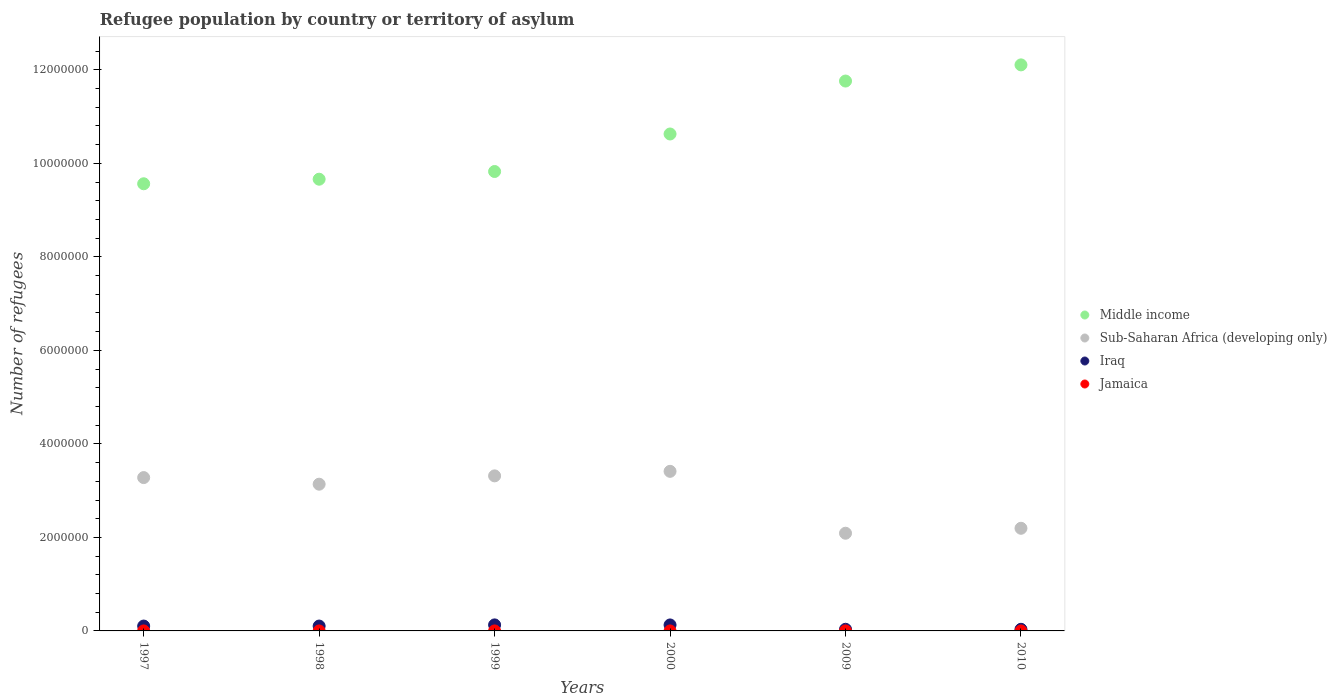How many different coloured dotlines are there?
Offer a very short reply. 4. Across all years, what is the maximum number of refugees in Middle income?
Keep it short and to the point. 1.21e+07. Across all years, what is the minimum number of refugees in Iraq?
Offer a terse response. 3.47e+04. In which year was the number of refugees in Iraq maximum?
Your answer should be compact. 1999. In which year was the number of refugees in Iraq minimum?
Your response must be concise. 2010. What is the total number of refugees in Sub-Saharan Africa (developing only) in the graph?
Ensure brevity in your answer.  1.74e+07. What is the difference between the number of refugees in Sub-Saharan Africa (developing only) in 1998 and that in 2010?
Your response must be concise. 9.43e+05. What is the difference between the number of refugees in Sub-Saharan Africa (developing only) in 1997 and the number of refugees in Jamaica in 2009?
Your response must be concise. 3.28e+06. What is the average number of refugees in Middle income per year?
Your answer should be very brief. 1.06e+07. In the year 2009, what is the difference between the number of refugees in Middle income and number of refugees in Jamaica?
Make the answer very short. 1.18e+07. What is the ratio of the number of refugees in Iraq in 2000 to that in 2009?
Give a very brief answer. 3.63. Is the number of refugees in Sub-Saharan Africa (developing only) in 1997 less than that in 2009?
Keep it short and to the point. No. Is the difference between the number of refugees in Middle income in 2009 and 2010 greater than the difference between the number of refugees in Jamaica in 2009 and 2010?
Provide a succinct answer. No. What is the difference between the highest and the second highest number of refugees in Iraq?
Give a very brief answer. 1126. What is the difference between the highest and the lowest number of refugees in Jamaica?
Provide a short and direct response. 17. In how many years, is the number of refugees in Sub-Saharan Africa (developing only) greater than the average number of refugees in Sub-Saharan Africa (developing only) taken over all years?
Your answer should be compact. 4. Is it the case that in every year, the sum of the number of refugees in Middle income and number of refugees in Iraq  is greater than the sum of number of refugees in Sub-Saharan Africa (developing only) and number of refugees in Jamaica?
Ensure brevity in your answer.  Yes. Does the number of refugees in Jamaica monotonically increase over the years?
Keep it short and to the point. No. Is the number of refugees in Iraq strictly less than the number of refugees in Jamaica over the years?
Keep it short and to the point. No. How many dotlines are there?
Provide a succinct answer. 4. How many years are there in the graph?
Provide a short and direct response. 6. What is the difference between two consecutive major ticks on the Y-axis?
Ensure brevity in your answer.  2.00e+06. Does the graph contain any zero values?
Provide a short and direct response. No. Does the graph contain grids?
Offer a terse response. No. How many legend labels are there?
Provide a succinct answer. 4. What is the title of the graph?
Your response must be concise. Refugee population by country or territory of asylum. Does "Gabon" appear as one of the legend labels in the graph?
Make the answer very short. No. What is the label or title of the X-axis?
Give a very brief answer. Years. What is the label or title of the Y-axis?
Provide a short and direct response. Number of refugees. What is the Number of refugees of Middle income in 1997?
Your response must be concise. 9.56e+06. What is the Number of refugees of Sub-Saharan Africa (developing only) in 1997?
Give a very brief answer. 3.28e+06. What is the Number of refugees in Iraq in 1997?
Your response must be concise. 1.04e+05. What is the Number of refugees of Middle income in 1998?
Make the answer very short. 9.66e+06. What is the Number of refugees of Sub-Saharan Africa (developing only) in 1998?
Offer a very short reply. 3.14e+06. What is the Number of refugees of Iraq in 1998?
Your answer should be very brief. 1.04e+05. What is the Number of refugees in Middle income in 1999?
Make the answer very short. 9.83e+06. What is the Number of refugees of Sub-Saharan Africa (developing only) in 1999?
Your answer should be compact. 3.32e+06. What is the Number of refugees of Iraq in 1999?
Ensure brevity in your answer.  1.29e+05. What is the Number of refugees of Jamaica in 1999?
Your answer should be compact. 37. What is the Number of refugees in Middle income in 2000?
Ensure brevity in your answer.  1.06e+07. What is the Number of refugees of Sub-Saharan Africa (developing only) in 2000?
Offer a terse response. 3.41e+06. What is the Number of refugees in Iraq in 2000?
Ensure brevity in your answer.  1.28e+05. What is the Number of refugees in Jamaica in 2000?
Your answer should be compact. 38. What is the Number of refugees in Middle income in 2009?
Provide a succinct answer. 1.18e+07. What is the Number of refugees in Sub-Saharan Africa (developing only) in 2009?
Provide a short and direct response. 2.09e+06. What is the Number of refugees of Iraq in 2009?
Make the answer very short. 3.52e+04. What is the Number of refugees in Jamaica in 2009?
Make the answer very short. 26. What is the Number of refugees in Middle income in 2010?
Your answer should be very brief. 1.21e+07. What is the Number of refugees in Sub-Saharan Africa (developing only) in 2010?
Give a very brief answer. 2.20e+06. What is the Number of refugees in Iraq in 2010?
Make the answer very short. 3.47e+04. What is the Number of refugees in Jamaica in 2010?
Your answer should be compact. 21. Across all years, what is the maximum Number of refugees in Middle income?
Offer a very short reply. 1.21e+07. Across all years, what is the maximum Number of refugees in Sub-Saharan Africa (developing only)?
Your answer should be very brief. 3.41e+06. Across all years, what is the maximum Number of refugees in Iraq?
Give a very brief answer. 1.29e+05. Across all years, what is the minimum Number of refugees of Middle income?
Offer a very short reply. 9.56e+06. Across all years, what is the minimum Number of refugees in Sub-Saharan Africa (developing only)?
Offer a terse response. 2.09e+06. Across all years, what is the minimum Number of refugees of Iraq?
Give a very brief answer. 3.47e+04. What is the total Number of refugees of Middle income in the graph?
Ensure brevity in your answer.  6.35e+07. What is the total Number of refugees in Sub-Saharan Africa (developing only) in the graph?
Ensure brevity in your answer.  1.74e+07. What is the total Number of refugees of Iraq in the graph?
Provide a succinct answer. 5.35e+05. What is the total Number of refugees of Jamaica in the graph?
Offer a terse response. 192. What is the difference between the Number of refugees in Middle income in 1997 and that in 1998?
Your answer should be compact. -9.76e+04. What is the difference between the Number of refugees of Sub-Saharan Africa (developing only) in 1997 and that in 1998?
Keep it short and to the point. 1.41e+05. What is the difference between the Number of refugees of Iraq in 1997 and that in 1998?
Your response must be concise. 10. What is the difference between the Number of refugees of Jamaica in 1997 and that in 1998?
Provide a short and direct response. -4. What is the difference between the Number of refugees of Middle income in 1997 and that in 1999?
Provide a succinct answer. -2.62e+05. What is the difference between the Number of refugees of Sub-Saharan Africa (developing only) in 1997 and that in 1999?
Your response must be concise. -3.68e+04. What is the difference between the Number of refugees in Iraq in 1997 and that in 1999?
Keep it short and to the point. -2.49e+04. What is the difference between the Number of refugees in Jamaica in 1997 and that in 1999?
Keep it short and to the point. -4. What is the difference between the Number of refugees of Middle income in 1997 and that in 2000?
Provide a short and direct response. -1.06e+06. What is the difference between the Number of refugees in Sub-Saharan Africa (developing only) in 1997 and that in 2000?
Provide a short and direct response. -1.34e+05. What is the difference between the Number of refugees in Iraq in 1997 and that in 2000?
Offer a terse response. -2.38e+04. What is the difference between the Number of refugees in Jamaica in 1997 and that in 2000?
Keep it short and to the point. -5. What is the difference between the Number of refugees in Middle income in 1997 and that in 2009?
Provide a succinct answer. -2.20e+06. What is the difference between the Number of refugees of Sub-Saharan Africa (developing only) in 1997 and that in 2009?
Keep it short and to the point. 1.19e+06. What is the difference between the Number of refugees of Iraq in 1997 and that in 2009?
Keep it short and to the point. 6.88e+04. What is the difference between the Number of refugees in Middle income in 1997 and that in 2010?
Provide a succinct answer. -2.54e+06. What is the difference between the Number of refugees in Sub-Saharan Africa (developing only) in 1997 and that in 2010?
Provide a short and direct response. 1.08e+06. What is the difference between the Number of refugees of Iraq in 1997 and that in 2010?
Ensure brevity in your answer.  6.94e+04. What is the difference between the Number of refugees in Jamaica in 1997 and that in 2010?
Provide a short and direct response. 12. What is the difference between the Number of refugees in Middle income in 1998 and that in 1999?
Provide a short and direct response. -1.65e+05. What is the difference between the Number of refugees in Sub-Saharan Africa (developing only) in 1998 and that in 1999?
Ensure brevity in your answer.  -1.78e+05. What is the difference between the Number of refugees in Iraq in 1998 and that in 1999?
Your response must be concise. -2.49e+04. What is the difference between the Number of refugees in Middle income in 1998 and that in 2000?
Your response must be concise. -9.67e+05. What is the difference between the Number of refugees in Sub-Saharan Africa (developing only) in 1998 and that in 2000?
Your answer should be compact. -2.75e+05. What is the difference between the Number of refugees in Iraq in 1998 and that in 2000?
Provide a succinct answer. -2.38e+04. What is the difference between the Number of refugees in Jamaica in 1998 and that in 2000?
Keep it short and to the point. -1. What is the difference between the Number of refugees of Middle income in 1998 and that in 2009?
Offer a very short reply. -2.10e+06. What is the difference between the Number of refugees of Sub-Saharan Africa (developing only) in 1998 and that in 2009?
Offer a terse response. 1.05e+06. What is the difference between the Number of refugees of Iraq in 1998 and that in 2009?
Provide a short and direct response. 6.88e+04. What is the difference between the Number of refugees in Middle income in 1998 and that in 2010?
Offer a very short reply. -2.45e+06. What is the difference between the Number of refugees in Sub-Saharan Africa (developing only) in 1998 and that in 2010?
Offer a very short reply. 9.43e+05. What is the difference between the Number of refugees in Iraq in 1998 and that in 2010?
Your answer should be very brief. 6.94e+04. What is the difference between the Number of refugees in Jamaica in 1998 and that in 2010?
Offer a terse response. 16. What is the difference between the Number of refugees of Middle income in 1999 and that in 2000?
Ensure brevity in your answer.  -8.02e+05. What is the difference between the Number of refugees in Sub-Saharan Africa (developing only) in 1999 and that in 2000?
Give a very brief answer. -9.69e+04. What is the difference between the Number of refugees of Iraq in 1999 and that in 2000?
Your response must be concise. 1126. What is the difference between the Number of refugees of Jamaica in 1999 and that in 2000?
Your answer should be very brief. -1. What is the difference between the Number of refugees of Middle income in 1999 and that in 2009?
Make the answer very short. -1.93e+06. What is the difference between the Number of refugees of Sub-Saharan Africa (developing only) in 1999 and that in 2009?
Offer a very short reply. 1.23e+06. What is the difference between the Number of refugees in Iraq in 1999 and that in 2009?
Make the answer very short. 9.37e+04. What is the difference between the Number of refugees in Jamaica in 1999 and that in 2009?
Keep it short and to the point. 11. What is the difference between the Number of refugees in Middle income in 1999 and that in 2010?
Offer a very short reply. -2.28e+06. What is the difference between the Number of refugees in Sub-Saharan Africa (developing only) in 1999 and that in 2010?
Keep it short and to the point. 1.12e+06. What is the difference between the Number of refugees of Iraq in 1999 and that in 2010?
Provide a succinct answer. 9.43e+04. What is the difference between the Number of refugees in Middle income in 2000 and that in 2009?
Offer a very short reply. -1.13e+06. What is the difference between the Number of refugees of Sub-Saharan Africa (developing only) in 2000 and that in 2009?
Provide a succinct answer. 1.32e+06. What is the difference between the Number of refugees of Iraq in 2000 and that in 2009?
Your response must be concise. 9.26e+04. What is the difference between the Number of refugees in Middle income in 2000 and that in 2010?
Give a very brief answer. -1.48e+06. What is the difference between the Number of refugees of Sub-Saharan Africa (developing only) in 2000 and that in 2010?
Keep it short and to the point. 1.22e+06. What is the difference between the Number of refugees of Iraq in 2000 and that in 2010?
Keep it short and to the point. 9.31e+04. What is the difference between the Number of refugees in Middle income in 2009 and that in 2010?
Ensure brevity in your answer.  -3.46e+05. What is the difference between the Number of refugees in Sub-Saharan Africa (developing only) in 2009 and that in 2010?
Your answer should be very brief. -1.06e+05. What is the difference between the Number of refugees of Iraq in 2009 and that in 2010?
Provide a short and direct response. 563. What is the difference between the Number of refugees in Jamaica in 2009 and that in 2010?
Your answer should be compact. 5. What is the difference between the Number of refugees of Middle income in 1997 and the Number of refugees of Sub-Saharan Africa (developing only) in 1998?
Your answer should be compact. 6.43e+06. What is the difference between the Number of refugees of Middle income in 1997 and the Number of refugees of Iraq in 1998?
Your answer should be very brief. 9.46e+06. What is the difference between the Number of refugees of Middle income in 1997 and the Number of refugees of Jamaica in 1998?
Your response must be concise. 9.56e+06. What is the difference between the Number of refugees in Sub-Saharan Africa (developing only) in 1997 and the Number of refugees in Iraq in 1998?
Give a very brief answer. 3.18e+06. What is the difference between the Number of refugees of Sub-Saharan Africa (developing only) in 1997 and the Number of refugees of Jamaica in 1998?
Make the answer very short. 3.28e+06. What is the difference between the Number of refugees of Iraq in 1997 and the Number of refugees of Jamaica in 1998?
Ensure brevity in your answer.  1.04e+05. What is the difference between the Number of refugees of Middle income in 1997 and the Number of refugees of Sub-Saharan Africa (developing only) in 1999?
Make the answer very short. 6.25e+06. What is the difference between the Number of refugees of Middle income in 1997 and the Number of refugees of Iraq in 1999?
Give a very brief answer. 9.44e+06. What is the difference between the Number of refugees in Middle income in 1997 and the Number of refugees in Jamaica in 1999?
Offer a terse response. 9.56e+06. What is the difference between the Number of refugees of Sub-Saharan Africa (developing only) in 1997 and the Number of refugees of Iraq in 1999?
Your answer should be compact. 3.15e+06. What is the difference between the Number of refugees in Sub-Saharan Africa (developing only) in 1997 and the Number of refugees in Jamaica in 1999?
Ensure brevity in your answer.  3.28e+06. What is the difference between the Number of refugees of Iraq in 1997 and the Number of refugees of Jamaica in 1999?
Your answer should be compact. 1.04e+05. What is the difference between the Number of refugees of Middle income in 1997 and the Number of refugees of Sub-Saharan Africa (developing only) in 2000?
Provide a succinct answer. 6.15e+06. What is the difference between the Number of refugees of Middle income in 1997 and the Number of refugees of Iraq in 2000?
Ensure brevity in your answer.  9.44e+06. What is the difference between the Number of refugees in Middle income in 1997 and the Number of refugees in Jamaica in 2000?
Make the answer very short. 9.56e+06. What is the difference between the Number of refugees of Sub-Saharan Africa (developing only) in 1997 and the Number of refugees of Iraq in 2000?
Ensure brevity in your answer.  3.15e+06. What is the difference between the Number of refugees of Sub-Saharan Africa (developing only) in 1997 and the Number of refugees of Jamaica in 2000?
Keep it short and to the point. 3.28e+06. What is the difference between the Number of refugees in Iraq in 1997 and the Number of refugees in Jamaica in 2000?
Ensure brevity in your answer.  1.04e+05. What is the difference between the Number of refugees in Middle income in 1997 and the Number of refugees in Sub-Saharan Africa (developing only) in 2009?
Ensure brevity in your answer.  7.47e+06. What is the difference between the Number of refugees in Middle income in 1997 and the Number of refugees in Iraq in 2009?
Keep it short and to the point. 9.53e+06. What is the difference between the Number of refugees in Middle income in 1997 and the Number of refugees in Jamaica in 2009?
Your answer should be very brief. 9.56e+06. What is the difference between the Number of refugees in Sub-Saharan Africa (developing only) in 1997 and the Number of refugees in Iraq in 2009?
Provide a short and direct response. 3.24e+06. What is the difference between the Number of refugees of Sub-Saharan Africa (developing only) in 1997 and the Number of refugees of Jamaica in 2009?
Offer a very short reply. 3.28e+06. What is the difference between the Number of refugees in Iraq in 1997 and the Number of refugees in Jamaica in 2009?
Your answer should be very brief. 1.04e+05. What is the difference between the Number of refugees in Middle income in 1997 and the Number of refugees in Sub-Saharan Africa (developing only) in 2010?
Offer a very short reply. 7.37e+06. What is the difference between the Number of refugees in Middle income in 1997 and the Number of refugees in Iraq in 2010?
Provide a short and direct response. 9.53e+06. What is the difference between the Number of refugees in Middle income in 1997 and the Number of refugees in Jamaica in 2010?
Ensure brevity in your answer.  9.56e+06. What is the difference between the Number of refugees in Sub-Saharan Africa (developing only) in 1997 and the Number of refugees in Iraq in 2010?
Give a very brief answer. 3.24e+06. What is the difference between the Number of refugees of Sub-Saharan Africa (developing only) in 1997 and the Number of refugees of Jamaica in 2010?
Make the answer very short. 3.28e+06. What is the difference between the Number of refugees in Iraq in 1997 and the Number of refugees in Jamaica in 2010?
Your answer should be very brief. 1.04e+05. What is the difference between the Number of refugees of Middle income in 1998 and the Number of refugees of Sub-Saharan Africa (developing only) in 1999?
Your response must be concise. 6.35e+06. What is the difference between the Number of refugees of Middle income in 1998 and the Number of refugees of Iraq in 1999?
Offer a terse response. 9.53e+06. What is the difference between the Number of refugees in Middle income in 1998 and the Number of refugees in Jamaica in 1999?
Your response must be concise. 9.66e+06. What is the difference between the Number of refugees of Sub-Saharan Africa (developing only) in 1998 and the Number of refugees of Iraq in 1999?
Provide a succinct answer. 3.01e+06. What is the difference between the Number of refugees of Sub-Saharan Africa (developing only) in 1998 and the Number of refugees of Jamaica in 1999?
Offer a terse response. 3.14e+06. What is the difference between the Number of refugees in Iraq in 1998 and the Number of refugees in Jamaica in 1999?
Keep it short and to the point. 1.04e+05. What is the difference between the Number of refugees in Middle income in 1998 and the Number of refugees in Sub-Saharan Africa (developing only) in 2000?
Your answer should be compact. 6.25e+06. What is the difference between the Number of refugees of Middle income in 1998 and the Number of refugees of Iraq in 2000?
Provide a short and direct response. 9.53e+06. What is the difference between the Number of refugees of Middle income in 1998 and the Number of refugees of Jamaica in 2000?
Your response must be concise. 9.66e+06. What is the difference between the Number of refugees in Sub-Saharan Africa (developing only) in 1998 and the Number of refugees in Iraq in 2000?
Make the answer very short. 3.01e+06. What is the difference between the Number of refugees of Sub-Saharan Africa (developing only) in 1998 and the Number of refugees of Jamaica in 2000?
Provide a short and direct response. 3.14e+06. What is the difference between the Number of refugees in Iraq in 1998 and the Number of refugees in Jamaica in 2000?
Your answer should be compact. 1.04e+05. What is the difference between the Number of refugees in Middle income in 1998 and the Number of refugees in Sub-Saharan Africa (developing only) in 2009?
Your answer should be very brief. 7.57e+06. What is the difference between the Number of refugees in Middle income in 1998 and the Number of refugees in Iraq in 2009?
Ensure brevity in your answer.  9.63e+06. What is the difference between the Number of refugees of Middle income in 1998 and the Number of refugees of Jamaica in 2009?
Make the answer very short. 9.66e+06. What is the difference between the Number of refugees in Sub-Saharan Africa (developing only) in 1998 and the Number of refugees in Iraq in 2009?
Provide a succinct answer. 3.10e+06. What is the difference between the Number of refugees of Sub-Saharan Africa (developing only) in 1998 and the Number of refugees of Jamaica in 2009?
Keep it short and to the point. 3.14e+06. What is the difference between the Number of refugees of Iraq in 1998 and the Number of refugees of Jamaica in 2009?
Provide a succinct answer. 1.04e+05. What is the difference between the Number of refugees in Middle income in 1998 and the Number of refugees in Sub-Saharan Africa (developing only) in 2010?
Provide a succinct answer. 7.47e+06. What is the difference between the Number of refugees in Middle income in 1998 and the Number of refugees in Iraq in 2010?
Provide a succinct answer. 9.63e+06. What is the difference between the Number of refugees of Middle income in 1998 and the Number of refugees of Jamaica in 2010?
Provide a short and direct response. 9.66e+06. What is the difference between the Number of refugees of Sub-Saharan Africa (developing only) in 1998 and the Number of refugees of Iraq in 2010?
Offer a terse response. 3.10e+06. What is the difference between the Number of refugees in Sub-Saharan Africa (developing only) in 1998 and the Number of refugees in Jamaica in 2010?
Provide a short and direct response. 3.14e+06. What is the difference between the Number of refugees in Iraq in 1998 and the Number of refugees in Jamaica in 2010?
Provide a short and direct response. 1.04e+05. What is the difference between the Number of refugees in Middle income in 1999 and the Number of refugees in Sub-Saharan Africa (developing only) in 2000?
Make the answer very short. 6.41e+06. What is the difference between the Number of refugees of Middle income in 1999 and the Number of refugees of Iraq in 2000?
Make the answer very short. 9.70e+06. What is the difference between the Number of refugees of Middle income in 1999 and the Number of refugees of Jamaica in 2000?
Provide a short and direct response. 9.83e+06. What is the difference between the Number of refugees in Sub-Saharan Africa (developing only) in 1999 and the Number of refugees in Iraq in 2000?
Your response must be concise. 3.19e+06. What is the difference between the Number of refugees in Sub-Saharan Africa (developing only) in 1999 and the Number of refugees in Jamaica in 2000?
Offer a very short reply. 3.32e+06. What is the difference between the Number of refugees in Iraq in 1999 and the Number of refugees in Jamaica in 2000?
Give a very brief answer. 1.29e+05. What is the difference between the Number of refugees of Middle income in 1999 and the Number of refugees of Sub-Saharan Africa (developing only) in 2009?
Provide a short and direct response. 7.74e+06. What is the difference between the Number of refugees in Middle income in 1999 and the Number of refugees in Iraq in 2009?
Give a very brief answer. 9.79e+06. What is the difference between the Number of refugees of Middle income in 1999 and the Number of refugees of Jamaica in 2009?
Give a very brief answer. 9.83e+06. What is the difference between the Number of refugees in Sub-Saharan Africa (developing only) in 1999 and the Number of refugees in Iraq in 2009?
Your answer should be very brief. 3.28e+06. What is the difference between the Number of refugees in Sub-Saharan Africa (developing only) in 1999 and the Number of refugees in Jamaica in 2009?
Offer a terse response. 3.32e+06. What is the difference between the Number of refugees of Iraq in 1999 and the Number of refugees of Jamaica in 2009?
Your response must be concise. 1.29e+05. What is the difference between the Number of refugees in Middle income in 1999 and the Number of refugees in Sub-Saharan Africa (developing only) in 2010?
Provide a succinct answer. 7.63e+06. What is the difference between the Number of refugees of Middle income in 1999 and the Number of refugees of Iraq in 2010?
Your answer should be compact. 9.79e+06. What is the difference between the Number of refugees of Middle income in 1999 and the Number of refugees of Jamaica in 2010?
Give a very brief answer. 9.83e+06. What is the difference between the Number of refugees in Sub-Saharan Africa (developing only) in 1999 and the Number of refugees in Iraq in 2010?
Your response must be concise. 3.28e+06. What is the difference between the Number of refugees in Sub-Saharan Africa (developing only) in 1999 and the Number of refugees in Jamaica in 2010?
Make the answer very short. 3.32e+06. What is the difference between the Number of refugees of Iraq in 1999 and the Number of refugees of Jamaica in 2010?
Keep it short and to the point. 1.29e+05. What is the difference between the Number of refugees of Middle income in 2000 and the Number of refugees of Sub-Saharan Africa (developing only) in 2009?
Offer a very short reply. 8.54e+06. What is the difference between the Number of refugees in Middle income in 2000 and the Number of refugees in Iraq in 2009?
Your answer should be very brief. 1.06e+07. What is the difference between the Number of refugees of Middle income in 2000 and the Number of refugees of Jamaica in 2009?
Keep it short and to the point. 1.06e+07. What is the difference between the Number of refugees of Sub-Saharan Africa (developing only) in 2000 and the Number of refugees of Iraq in 2009?
Give a very brief answer. 3.38e+06. What is the difference between the Number of refugees in Sub-Saharan Africa (developing only) in 2000 and the Number of refugees in Jamaica in 2009?
Your answer should be very brief. 3.41e+06. What is the difference between the Number of refugees of Iraq in 2000 and the Number of refugees of Jamaica in 2009?
Your response must be concise. 1.28e+05. What is the difference between the Number of refugees in Middle income in 2000 and the Number of refugees in Sub-Saharan Africa (developing only) in 2010?
Your answer should be compact. 8.43e+06. What is the difference between the Number of refugees of Middle income in 2000 and the Number of refugees of Iraq in 2010?
Keep it short and to the point. 1.06e+07. What is the difference between the Number of refugees of Middle income in 2000 and the Number of refugees of Jamaica in 2010?
Your response must be concise. 1.06e+07. What is the difference between the Number of refugees of Sub-Saharan Africa (developing only) in 2000 and the Number of refugees of Iraq in 2010?
Ensure brevity in your answer.  3.38e+06. What is the difference between the Number of refugees in Sub-Saharan Africa (developing only) in 2000 and the Number of refugees in Jamaica in 2010?
Offer a very short reply. 3.41e+06. What is the difference between the Number of refugees of Iraq in 2000 and the Number of refugees of Jamaica in 2010?
Ensure brevity in your answer.  1.28e+05. What is the difference between the Number of refugees of Middle income in 2009 and the Number of refugees of Sub-Saharan Africa (developing only) in 2010?
Your response must be concise. 9.57e+06. What is the difference between the Number of refugees in Middle income in 2009 and the Number of refugees in Iraq in 2010?
Keep it short and to the point. 1.17e+07. What is the difference between the Number of refugees of Middle income in 2009 and the Number of refugees of Jamaica in 2010?
Offer a very short reply. 1.18e+07. What is the difference between the Number of refugees of Sub-Saharan Africa (developing only) in 2009 and the Number of refugees of Iraq in 2010?
Provide a succinct answer. 2.05e+06. What is the difference between the Number of refugees in Sub-Saharan Africa (developing only) in 2009 and the Number of refugees in Jamaica in 2010?
Offer a terse response. 2.09e+06. What is the difference between the Number of refugees of Iraq in 2009 and the Number of refugees of Jamaica in 2010?
Provide a succinct answer. 3.52e+04. What is the average Number of refugees of Middle income per year?
Ensure brevity in your answer.  1.06e+07. What is the average Number of refugees in Sub-Saharan Africa (developing only) per year?
Your answer should be compact. 2.91e+06. What is the average Number of refugees of Iraq per year?
Make the answer very short. 8.91e+04. In the year 1997, what is the difference between the Number of refugees of Middle income and Number of refugees of Sub-Saharan Africa (developing only)?
Ensure brevity in your answer.  6.28e+06. In the year 1997, what is the difference between the Number of refugees in Middle income and Number of refugees in Iraq?
Give a very brief answer. 9.46e+06. In the year 1997, what is the difference between the Number of refugees in Middle income and Number of refugees in Jamaica?
Make the answer very short. 9.56e+06. In the year 1997, what is the difference between the Number of refugees of Sub-Saharan Africa (developing only) and Number of refugees of Iraq?
Provide a short and direct response. 3.18e+06. In the year 1997, what is the difference between the Number of refugees in Sub-Saharan Africa (developing only) and Number of refugees in Jamaica?
Provide a succinct answer. 3.28e+06. In the year 1997, what is the difference between the Number of refugees in Iraq and Number of refugees in Jamaica?
Keep it short and to the point. 1.04e+05. In the year 1998, what is the difference between the Number of refugees in Middle income and Number of refugees in Sub-Saharan Africa (developing only)?
Make the answer very short. 6.52e+06. In the year 1998, what is the difference between the Number of refugees of Middle income and Number of refugees of Iraq?
Provide a short and direct response. 9.56e+06. In the year 1998, what is the difference between the Number of refugees of Middle income and Number of refugees of Jamaica?
Your response must be concise. 9.66e+06. In the year 1998, what is the difference between the Number of refugees in Sub-Saharan Africa (developing only) and Number of refugees in Iraq?
Your answer should be very brief. 3.03e+06. In the year 1998, what is the difference between the Number of refugees in Sub-Saharan Africa (developing only) and Number of refugees in Jamaica?
Offer a very short reply. 3.14e+06. In the year 1998, what is the difference between the Number of refugees in Iraq and Number of refugees in Jamaica?
Give a very brief answer. 1.04e+05. In the year 1999, what is the difference between the Number of refugees in Middle income and Number of refugees in Sub-Saharan Africa (developing only)?
Make the answer very short. 6.51e+06. In the year 1999, what is the difference between the Number of refugees of Middle income and Number of refugees of Iraq?
Provide a short and direct response. 9.70e+06. In the year 1999, what is the difference between the Number of refugees of Middle income and Number of refugees of Jamaica?
Your answer should be compact. 9.83e+06. In the year 1999, what is the difference between the Number of refugees of Sub-Saharan Africa (developing only) and Number of refugees of Iraq?
Make the answer very short. 3.19e+06. In the year 1999, what is the difference between the Number of refugees of Sub-Saharan Africa (developing only) and Number of refugees of Jamaica?
Provide a short and direct response. 3.32e+06. In the year 1999, what is the difference between the Number of refugees in Iraq and Number of refugees in Jamaica?
Offer a very short reply. 1.29e+05. In the year 2000, what is the difference between the Number of refugees in Middle income and Number of refugees in Sub-Saharan Africa (developing only)?
Keep it short and to the point. 7.22e+06. In the year 2000, what is the difference between the Number of refugees of Middle income and Number of refugees of Iraq?
Your answer should be compact. 1.05e+07. In the year 2000, what is the difference between the Number of refugees of Middle income and Number of refugees of Jamaica?
Make the answer very short. 1.06e+07. In the year 2000, what is the difference between the Number of refugees in Sub-Saharan Africa (developing only) and Number of refugees in Iraq?
Offer a very short reply. 3.29e+06. In the year 2000, what is the difference between the Number of refugees of Sub-Saharan Africa (developing only) and Number of refugees of Jamaica?
Keep it short and to the point. 3.41e+06. In the year 2000, what is the difference between the Number of refugees in Iraq and Number of refugees in Jamaica?
Your answer should be very brief. 1.28e+05. In the year 2009, what is the difference between the Number of refugees of Middle income and Number of refugees of Sub-Saharan Africa (developing only)?
Your answer should be compact. 9.67e+06. In the year 2009, what is the difference between the Number of refugees of Middle income and Number of refugees of Iraq?
Your answer should be compact. 1.17e+07. In the year 2009, what is the difference between the Number of refugees in Middle income and Number of refugees in Jamaica?
Make the answer very short. 1.18e+07. In the year 2009, what is the difference between the Number of refugees of Sub-Saharan Africa (developing only) and Number of refugees of Iraq?
Offer a very short reply. 2.05e+06. In the year 2009, what is the difference between the Number of refugees in Sub-Saharan Africa (developing only) and Number of refugees in Jamaica?
Offer a terse response. 2.09e+06. In the year 2009, what is the difference between the Number of refugees of Iraq and Number of refugees of Jamaica?
Make the answer very short. 3.52e+04. In the year 2010, what is the difference between the Number of refugees in Middle income and Number of refugees in Sub-Saharan Africa (developing only)?
Your answer should be very brief. 9.91e+06. In the year 2010, what is the difference between the Number of refugees in Middle income and Number of refugees in Iraq?
Keep it short and to the point. 1.21e+07. In the year 2010, what is the difference between the Number of refugees in Middle income and Number of refugees in Jamaica?
Provide a succinct answer. 1.21e+07. In the year 2010, what is the difference between the Number of refugees of Sub-Saharan Africa (developing only) and Number of refugees of Iraq?
Your response must be concise. 2.16e+06. In the year 2010, what is the difference between the Number of refugees in Sub-Saharan Africa (developing only) and Number of refugees in Jamaica?
Your answer should be compact. 2.20e+06. In the year 2010, what is the difference between the Number of refugees of Iraq and Number of refugees of Jamaica?
Keep it short and to the point. 3.46e+04. What is the ratio of the Number of refugees of Sub-Saharan Africa (developing only) in 1997 to that in 1998?
Provide a short and direct response. 1.04. What is the ratio of the Number of refugees in Jamaica in 1997 to that in 1998?
Keep it short and to the point. 0.89. What is the ratio of the Number of refugees in Middle income in 1997 to that in 1999?
Provide a short and direct response. 0.97. What is the ratio of the Number of refugees in Sub-Saharan Africa (developing only) in 1997 to that in 1999?
Provide a short and direct response. 0.99. What is the ratio of the Number of refugees in Iraq in 1997 to that in 1999?
Give a very brief answer. 0.81. What is the ratio of the Number of refugees of Jamaica in 1997 to that in 1999?
Offer a very short reply. 0.89. What is the ratio of the Number of refugees in Middle income in 1997 to that in 2000?
Your answer should be compact. 0.9. What is the ratio of the Number of refugees in Sub-Saharan Africa (developing only) in 1997 to that in 2000?
Offer a terse response. 0.96. What is the ratio of the Number of refugees in Iraq in 1997 to that in 2000?
Provide a short and direct response. 0.81. What is the ratio of the Number of refugees of Jamaica in 1997 to that in 2000?
Keep it short and to the point. 0.87. What is the ratio of the Number of refugees in Middle income in 1997 to that in 2009?
Provide a short and direct response. 0.81. What is the ratio of the Number of refugees in Sub-Saharan Africa (developing only) in 1997 to that in 2009?
Provide a short and direct response. 1.57. What is the ratio of the Number of refugees of Iraq in 1997 to that in 2009?
Keep it short and to the point. 2.95. What is the ratio of the Number of refugees in Jamaica in 1997 to that in 2009?
Offer a terse response. 1.27. What is the ratio of the Number of refugees of Middle income in 1997 to that in 2010?
Ensure brevity in your answer.  0.79. What is the ratio of the Number of refugees in Sub-Saharan Africa (developing only) in 1997 to that in 2010?
Offer a very short reply. 1.49. What is the ratio of the Number of refugees in Iraq in 1997 to that in 2010?
Your answer should be compact. 3. What is the ratio of the Number of refugees of Jamaica in 1997 to that in 2010?
Provide a short and direct response. 1.57. What is the ratio of the Number of refugees of Middle income in 1998 to that in 1999?
Your answer should be very brief. 0.98. What is the ratio of the Number of refugees of Sub-Saharan Africa (developing only) in 1998 to that in 1999?
Your answer should be compact. 0.95. What is the ratio of the Number of refugees of Iraq in 1998 to that in 1999?
Provide a short and direct response. 0.81. What is the ratio of the Number of refugees in Jamaica in 1998 to that in 1999?
Your answer should be compact. 1. What is the ratio of the Number of refugees in Middle income in 1998 to that in 2000?
Offer a terse response. 0.91. What is the ratio of the Number of refugees of Sub-Saharan Africa (developing only) in 1998 to that in 2000?
Ensure brevity in your answer.  0.92. What is the ratio of the Number of refugees in Iraq in 1998 to that in 2000?
Offer a terse response. 0.81. What is the ratio of the Number of refugees of Jamaica in 1998 to that in 2000?
Offer a very short reply. 0.97. What is the ratio of the Number of refugees in Middle income in 1998 to that in 2009?
Provide a short and direct response. 0.82. What is the ratio of the Number of refugees of Sub-Saharan Africa (developing only) in 1998 to that in 2009?
Provide a succinct answer. 1.5. What is the ratio of the Number of refugees in Iraq in 1998 to that in 2009?
Make the answer very short. 2.95. What is the ratio of the Number of refugees of Jamaica in 1998 to that in 2009?
Your answer should be compact. 1.42. What is the ratio of the Number of refugees in Middle income in 1998 to that in 2010?
Keep it short and to the point. 0.8. What is the ratio of the Number of refugees in Sub-Saharan Africa (developing only) in 1998 to that in 2010?
Your answer should be compact. 1.43. What is the ratio of the Number of refugees in Iraq in 1998 to that in 2010?
Ensure brevity in your answer.  3. What is the ratio of the Number of refugees of Jamaica in 1998 to that in 2010?
Your answer should be very brief. 1.76. What is the ratio of the Number of refugees of Middle income in 1999 to that in 2000?
Ensure brevity in your answer.  0.92. What is the ratio of the Number of refugees in Sub-Saharan Africa (developing only) in 1999 to that in 2000?
Keep it short and to the point. 0.97. What is the ratio of the Number of refugees in Iraq in 1999 to that in 2000?
Make the answer very short. 1.01. What is the ratio of the Number of refugees of Jamaica in 1999 to that in 2000?
Ensure brevity in your answer.  0.97. What is the ratio of the Number of refugees in Middle income in 1999 to that in 2009?
Offer a very short reply. 0.84. What is the ratio of the Number of refugees of Sub-Saharan Africa (developing only) in 1999 to that in 2009?
Your answer should be compact. 1.59. What is the ratio of the Number of refugees in Iraq in 1999 to that in 2009?
Make the answer very short. 3.66. What is the ratio of the Number of refugees of Jamaica in 1999 to that in 2009?
Keep it short and to the point. 1.42. What is the ratio of the Number of refugees of Middle income in 1999 to that in 2010?
Offer a terse response. 0.81. What is the ratio of the Number of refugees in Sub-Saharan Africa (developing only) in 1999 to that in 2010?
Your answer should be compact. 1.51. What is the ratio of the Number of refugees in Iraq in 1999 to that in 2010?
Give a very brief answer. 3.72. What is the ratio of the Number of refugees in Jamaica in 1999 to that in 2010?
Your answer should be very brief. 1.76. What is the ratio of the Number of refugees in Middle income in 2000 to that in 2009?
Offer a terse response. 0.9. What is the ratio of the Number of refugees in Sub-Saharan Africa (developing only) in 2000 to that in 2009?
Your response must be concise. 1.63. What is the ratio of the Number of refugees in Iraq in 2000 to that in 2009?
Your answer should be compact. 3.63. What is the ratio of the Number of refugees of Jamaica in 2000 to that in 2009?
Make the answer very short. 1.46. What is the ratio of the Number of refugees of Middle income in 2000 to that in 2010?
Offer a very short reply. 0.88. What is the ratio of the Number of refugees of Sub-Saharan Africa (developing only) in 2000 to that in 2010?
Provide a succinct answer. 1.55. What is the ratio of the Number of refugees in Iraq in 2000 to that in 2010?
Your answer should be very brief. 3.69. What is the ratio of the Number of refugees in Jamaica in 2000 to that in 2010?
Provide a short and direct response. 1.81. What is the ratio of the Number of refugees in Middle income in 2009 to that in 2010?
Ensure brevity in your answer.  0.97. What is the ratio of the Number of refugees in Sub-Saharan Africa (developing only) in 2009 to that in 2010?
Offer a terse response. 0.95. What is the ratio of the Number of refugees in Iraq in 2009 to that in 2010?
Provide a succinct answer. 1.02. What is the ratio of the Number of refugees in Jamaica in 2009 to that in 2010?
Provide a short and direct response. 1.24. What is the difference between the highest and the second highest Number of refugees in Middle income?
Make the answer very short. 3.46e+05. What is the difference between the highest and the second highest Number of refugees in Sub-Saharan Africa (developing only)?
Your response must be concise. 9.69e+04. What is the difference between the highest and the second highest Number of refugees in Iraq?
Offer a terse response. 1126. What is the difference between the highest and the lowest Number of refugees of Middle income?
Offer a terse response. 2.54e+06. What is the difference between the highest and the lowest Number of refugees in Sub-Saharan Africa (developing only)?
Make the answer very short. 1.32e+06. What is the difference between the highest and the lowest Number of refugees in Iraq?
Offer a very short reply. 9.43e+04. 